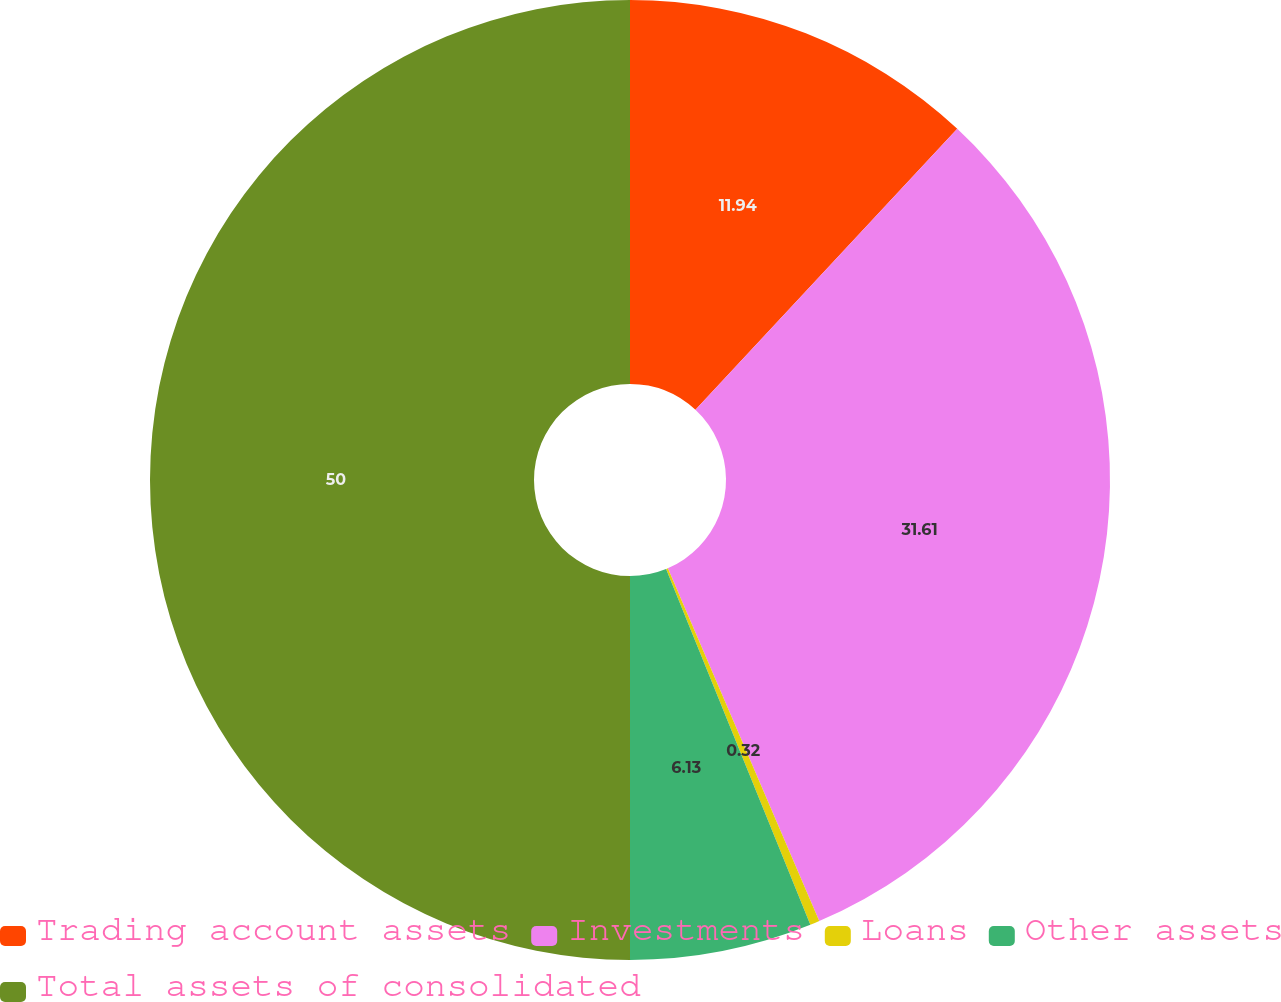Convert chart to OTSL. <chart><loc_0><loc_0><loc_500><loc_500><pie_chart><fcel>Trading account assets<fcel>Investments<fcel>Loans<fcel>Other assets<fcel>Total assets of consolidated<nl><fcel>11.94%<fcel>31.61%<fcel>0.32%<fcel>6.13%<fcel>50.0%<nl></chart> 